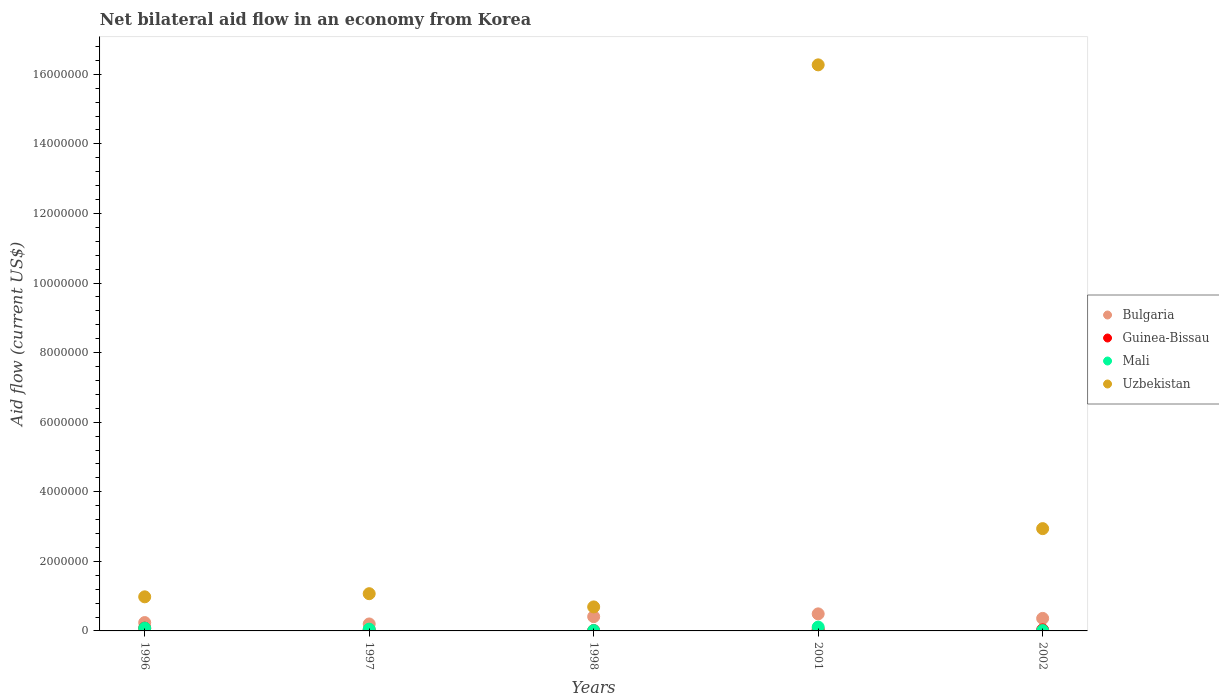Is the number of dotlines equal to the number of legend labels?
Make the answer very short. Yes. What is the net bilateral aid flow in Mali in 2002?
Your answer should be compact. 10000. Across all years, what is the minimum net bilateral aid flow in Guinea-Bissau?
Your response must be concise. 10000. In which year was the net bilateral aid flow in Uzbekistan maximum?
Ensure brevity in your answer.  2001. In which year was the net bilateral aid flow in Mali minimum?
Provide a succinct answer. 1998. What is the total net bilateral aid flow in Mali in the graph?
Make the answer very short. 2.60e+05. What is the difference between the net bilateral aid flow in Uzbekistan in 1998 and the net bilateral aid flow in Mali in 1997?
Your answer should be compact. 6.40e+05. What is the average net bilateral aid flow in Mali per year?
Ensure brevity in your answer.  5.20e+04. What is the difference between the highest and the second highest net bilateral aid flow in Mali?
Offer a very short reply. 3.00e+04. In how many years, is the net bilateral aid flow in Guinea-Bissau greater than the average net bilateral aid flow in Guinea-Bissau taken over all years?
Provide a short and direct response. 2. Is the sum of the net bilateral aid flow in Mali in 1997 and 1998 greater than the maximum net bilateral aid flow in Bulgaria across all years?
Give a very brief answer. No. Is it the case that in every year, the sum of the net bilateral aid flow in Mali and net bilateral aid flow in Bulgaria  is greater than the net bilateral aid flow in Uzbekistan?
Give a very brief answer. No. Is the net bilateral aid flow in Mali strictly greater than the net bilateral aid flow in Uzbekistan over the years?
Offer a terse response. No. Is the net bilateral aid flow in Guinea-Bissau strictly less than the net bilateral aid flow in Bulgaria over the years?
Provide a succinct answer. Yes. How many years are there in the graph?
Offer a very short reply. 5. What is the difference between two consecutive major ticks on the Y-axis?
Keep it short and to the point. 2.00e+06. Are the values on the major ticks of Y-axis written in scientific E-notation?
Keep it short and to the point. No. Does the graph contain any zero values?
Offer a terse response. No. Does the graph contain grids?
Give a very brief answer. No. How many legend labels are there?
Ensure brevity in your answer.  4. How are the legend labels stacked?
Your answer should be very brief. Vertical. What is the title of the graph?
Provide a short and direct response. Net bilateral aid flow in an economy from Korea. Does "American Samoa" appear as one of the legend labels in the graph?
Your answer should be compact. No. What is the Aid flow (current US$) of Guinea-Bissau in 1996?
Give a very brief answer. 8.00e+04. What is the Aid flow (current US$) in Mali in 1996?
Give a very brief answer. 8.00e+04. What is the Aid flow (current US$) of Uzbekistan in 1996?
Provide a succinct answer. 9.80e+05. What is the Aid flow (current US$) of Bulgaria in 1997?
Provide a succinct answer. 2.00e+05. What is the Aid flow (current US$) in Guinea-Bissau in 1997?
Provide a short and direct response. 3.00e+04. What is the Aid flow (current US$) in Mali in 1997?
Your answer should be very brief. 5.00e+04. What is the Aid flow (current US$) in Uzbekistan in 1997?
Your response must be concise. 1.07e+06. What is the Aid flow (current US$) of Mali in 1998?
Ensure brevity in your answer.  10000. What is the Aid flow (current US$) in Uzbekistan in 1998?
Your answer should be compact. 6.90e+05. What is the Aid flow (current US$) in Mali in 2001?
Provide a succinct answer. 1.10e+05. What is the Aid flow (current US$) in Uzbekistan in 2001?
Make the answer very short. 1.63e+07. What is the Aid flow (current US$) of Uzbekistan in 2002?
Give a very brief answer. 2.94e+06. Across all years, what is the maximum Aid flow (current US$) of Guinea-Bissau?
Provide a short and direct response. 8.00e+04. Across all years, what is the maximum Aid flow (current US$) in Mali?
Your answer should be compact. 1.10e+05. Across all years, what is the maximum Aid flow (current US$) of Uzbekistan?
Provide a succinct answer. 1.63e+07. Across all years, what is the minimum Aid flow (current US$) of Guinea-Bissau?
Your response must be concise. 10000. Across all years, what is the minimum Aid flow (current US$) of Mali?
Provide a succinct answer. 10000. Across all years, what is the minimum Aid flow (current US$) of Uzbekistan?
Ensure brevity in your answer.  6.90e+05. What is the total Aid flow (current US$) of Bulgaria in the graph?
Provide a succinct answer. 1.70e+06. What is the total Aid flow (current US$) of Uzbekistan in the graph?
Provide a short and direct response. 2.20e+07. What is the difference between the Aid flow (current US$) of Bulgaria in 1996 and that in 1997?
Provide a succinct answer. 4.00e+04. What is the difference between the Aid flow (current US$) in Uzbekistan in 1996 and that in 1998?
Offer a terse response. 2.90e+05. What is the difference between the Aid flow (current US$) of Guinea-Bissau in 1996 and that in 2001?
Offer a terse response. 4.00e+04. What is the difference between the Aid flow (current US$) of Uzbekistan in 1996 and that in 2001?
Make the answer very short. -1.53e+07. What is the difference between the Aid flow (current US$) of Guinea-Bissau in 1996 and that in 2002?
Provide a short and direct response. 5.00e+04. What is the difference between the Aid flow (current US$) of Mali in 1996 and that in 2002?
Provide a short and direct response. 7.00e+04. What is the difference between the Aid flow (current US$) of Uzbekistan in 1996 and that in 2002?
Provide a short and direct response. -1.96e+06. What is the difference between the Aid flow (current US$) of Mali in 1997 and that in 1998?
Offer a very short reply. 4.00e+04. What is the difference between the Aid flow (current US$) in Uzbekistan in 1997 and that in 1998?
Ensure brevity in your answer.  3.80e+05. What is the difference between the Aid flow (current US$) of Uzbekistan in 1997 and that in 2001?
Provide a short and direct response. -1.52e+07. What is the difference between the Aid flow (current US$) in Guinea-Bissau in 1997 and that in 2002?
Your answer should be compact. 0. What is the difference between the Aid flow (current US$) of Uzbekistan in 1997 and that in 2002?
Your answer should be very brief. -1.87e+06. What is the difference between the Aid flow (current US$) in Guinea-Bissau in 1998 and that in 2001?
Offer a very short reply. -3.00e+04. What is the difference between the Aid flow (current US$) of Mali in 1998 and that in 2001?
Provide a short and direct response. -1.00e+05. What is the difference between the Aid flow (current US$) of Uzbekistan in 1998 and that in 2001?
Keep it short and to the point. -1.56e+07. What is the difference between the Aid flow (current US$) of Bulgaria in 1998 and that in 2002?
Your response must be concise. 5.00e+04. What is the difference between the Aid flow (current US$) of Guinea-Bissau in 1998 and that in 2002?
Make the answer very short. -2.00e+04. What is the difference between the Aid flow (current US$) of Uzbekistan in 1998 and that in 2002?
Keep it short and to the point. -2.25e+06. What is the difference between the Aid flow (current US$) in Bulgaria in 2001 and that in 2002?
Offer a terse response. 1.30e+05. What is the difference between the Aid flow (current US$) of Uzbekistan in 2001 and that in 2002?
Your response must be concise. 1.33e+07. What is the difference between the Aid flow (current US$) in Bulgaria in 1996 and the Aid flow (current US$) in Guinea-Bissau in 1997?
Provide a short and direct response. 2.10e+05. What is the difference between the Aid flow (current US$) of Bulgaria in 1996 and the Aid flow (current US$) of Uzbekistan in 1997?
Offer a very short reply. -8.30e+05. What is the difference between the Aid flow (current US$) of Guinea-Bissau in 1996 and the Aid flow (current US$) of Uzbekistan in 1997?
Your answer should be very brief. -9.90e+05. What is the difference between the Aid flow (current US$) of Mali in 1996 and the Aid flow (current US$) of Uzbekistan in 1997?
Provide a short and direct response. -9.90e+05. What is the difference between the Aid flow (current US$) of Bulgaria in 1996 and the Aid flow (current US$) of Uzbekistan in 1998?
Your answer should be compact. -4.50e+05. What is the difference between the Aid flow (current US$) of Guinea-Bissau in 1996 and the Aid flow (current US$) of Uzbekistan in 1998?
Keep it short and to the point. -6.10e+05. What is the difference between the Aid flow (current US$) of Mali in 1996 and the Aid flow (current US$) of Uzbekistan in 1998?
Provide a short and direct response. -6.10e+05. What is the difference between the Aid flow (current US$) of Bulgaria in 1996 and the Aid flow (current US$) of Mali in 2001?
Provide a short and direct response. 1.30e+05. What is the difference between the Aid flow (current US$) of Bulgaria in 1996 and the Aid flow (current US$) of Uzbekistan in 2001?
Keep it short and to the point. -1.60e+07. What is the difference between the Aid flow (current US$) of Guinea-Bissau in 1996 and the Aid flow (current US$) of Mali in 2001?
Offer a terse response. -3.00e+04. What is the difference between the Aid flow (current US$) in Guinea-Bissau in 1996 and the Aid flow (current US$) in Uzbekistan in 2001?
Your answer should be very brief. -1.62e+07. What is the difference between the Aid flow (current US$) of Mali in 1996 and the Aid flow (current US$) of Uzbekistan in 2001?
Your response must be concise. -1.62e+07. What is the difference between the Aid flow (current US$) of Bulgaria in 1996 and the Aid flow (current US$) of Guinea-Bissau in 2002?
Give a very brief answer. 2.10e+05. What is the difference between the Aid flow (current US$) in Bulgaria in 1996 and the Aid flow (current US$) in Mali in 2002?
Keep it short and to the point. 2.30e+05. What is the difference between the Aid flow (current US$) in Bulgaria in 1996 and the Aid flow (current US$) in Uzbekistan in 2002?
Give a very brief answer. -2.70e+06. What is the difference between the Aid flow (current US$) of Guinea-Bissau in 1996 and the Aid flow (current US$) of Uzbekistan in 2002?
Provide a succinct answer. -2.86e+06. What is the difference between the Aid flow (current US$) in Mali in 1996 and the Aid flow (current US$) in Uzbekistan in 2002?
Provide a short and direct response. -2.86e+06. What is the difference between the Aid flow (current US$) in Bulgaria in 1997 and the Aid flow (current US$) in Guinea-Bissau in 1998?
Give a very brief answer. 1.90e+05. What is the difference between the Aid flow (current US$) in Bulgaria in 1997 and the Aid flow (current US$) in Uzbekistan in 1998?
Ensure brevity in your answer.  -4.90e+05. What is the difference between the Aid flow (current US$) of Guinea-Bissau in 1997 and the Aid flow (current US$) of Mali in 1998?
Your response must be concise. 2.00e+04. What is the difference between the Aid flow (current US$) in Guinea-Bissau in 1997 and the Aid flow (current US$) in Uzbekistan in 1998?
Give a very brief answer. -6.60e+05. What is the difference between the Aid flow (current US$) of Mali in 1997 and the Aid flow (current US$) of Uzbekistan in 1998?
Offer a very short reply. -6.40e+05. What is the difference between the Aid flow (current US$) of Bulgaria in 1997 and the Aid flow (current US$) of Mali in 2001?
Your response must be concise. 9.00e+04. What is the difference between the Aid flow (current US$) in Bulgaria in 1997 and the Aid flow (current US$) in Uzbekistan in 2001?
Ensure brevity in your answer.  -1.61e+07. What is the difference between the Aid flow (current US$) in Guinea-Bissau in 1997 and the Aid flow (current US$) in Uzbekistan in 2001?
Provide a succinct answer. -1.62e+07. What is the difference between the Aid flow (current US$) in Mali in 1997 and the Aid flow (current US$) in Uzbekistan in 2001?
Offer a very short reply. -1.62e+07. What is the difference between the Aid flow (current US$) in Bulgaria in 1997 and the Aid flow (current US$) in Guinea-Bissau in 2002?
Provide a short and direct response. 1.70e+05. What is the difference between the Aid flow (current US$) in Bulgaria in 1997 and the Aid flow (current US$) in Mali in 2002?
Your response must be concise. 1.90e+05. What is the difference between the Aid flow (current US$) in Bulgaria in 1997 and the Aid flow (current US$) in Uzbekistan in 2002?
Offer a terse response. -2.74e+06. What is the difference between the Aid flow (current US$) of Guinea-Bissau in 1997 and the Aid flow (current US$) of Uzbekistan in 2002?
Your answer should be very brief. -2.91e+06. What is the difference between the Aid flow (current US$) of Mali in 1997 and the Aid flow (current US$) of Uzbekistan in 2002?
Offer a very short reply. -2.89e+06. What is the difference between the Aid flow (current US$) in Bulgaria in 1998 and the Aid flow (current US$) in Guinea-Bissau in 2001?
Keep it short and to the point. 3.70e+05. What is the difference between the Aid flow (current US$) of Bulgaria in 1998 and the Aid flow (current US$) of Mali in 2001?
Give a very brief answer. 3.00e+05. What is the difference between the Aid flow (current US$) of Bulgaria in 1998 and the Aid flow (current US$) of Uzbekistan in 2001?
Offer a very short reply. -1.59e+07. What is the difference between the Aid flow (current US$) in Guinea-Bissau in 1998 and the Aid flow (current US$) in Mali in 2001?
Give a very brief answer. -1.00e+05. What is the difference between the Aid flow (current US$) of Guinea-Bissau in 1998 and the Aid flow (current US$) of Uzbekistan in 2001?
Ensure brevity in your answer.  -1.63e+07. What is the difference between the Aid flow (current US$) in Mali in 1998 and the Aid flow (current US$) in Uzbekistan in 2001?
Ensure brevity in your answer.  -1.63e+07. What is the difference between the Aid flow (current US$) of Bulgaria in 1998 and the Aid flow (current US$) of Guinea-Bissau in 2002?
Make the answer very short. 3.80e+05. What is the difference between the Aid flow (current US$) in Bulgaria in 1998 and the Aid flow (current US$) in Mali in 2002?
Offer a very short reply. 4.00e+05. What is the difference between the Aid flow (current US$) of Bulgaria in 1998 and the Aid flow (current US$) of Uzbekistan in 2002?
Ensure brevity in your answer.  -2.53e+06. What is the difference between the Aid flow (current US$) of Guinea-Bissau in 1998 and the Aid flow (current US$) of Uzbekistan in 2002?
Give a very brief answer. -2.93e+06. What is the difference between the Aid flow (current US$) in Mali in 1998 and the Aid flow (current US$) in Uzbekistan in 2002?
Your answer should be compact. -2.93e+06. What is the difference between the Aid flow (current US$) of Bulgaria in 2001 and the Aid flow (current US$) of Guinea-Bissau in 2002?
Provide a short and direct response. 4.60e+05. What is the difference between the Aid flow (current US$) in Bulgaria in 2001 and the Aid flow (current US$) in Uzbekistan in 2002?
Your answer should be very brief. -2.45e+06. What is the difference between the Aid flow (current US$) in Guinea-Bissau in 2001 and the Aid flow (current US$) in Mali in 2002?
Your answer should be very brief. 3.00e+04. What is the difference between the Aid flow (current US$) of Guinea-Bissau in 2001 and the Aid flow (current US$) of Uzbekistan in 2002?
Your answer should be very brief. -2.90e+06. What is the difference between the Aid flow (current US$) in Mali in 2001 and the Aid flow (current US$) in Uzbekistan in 2002?
Your answer should be very brief. -2.83e+06. What is the average Aid flow (current US$) of Bulgaria per year?
Make the answer very short. 3.40e+05. What is the average Aid flow (current US$) of Guinea-Bissau per year?
Ensure brevity in your answer.  3.80e+04. What is the average Aid flow (current US$) in Mali per year?
Give a very brief answer. 5.20e+04. What is the average Aid flow (current US$) in Uzbekistan per year?
Provide a short and direct response. 4.39e+06. In the year 1996, what is the difference between the Aid flow (current US$) in Bulgaria and Aid flow (current US$) in Guinea-Bissau?
Give a very brief answer. 1.60e+05. In the year 1996, what is the difference between the Aid flow (current US$) in Bulgaria and Aid flow (current US$) in Mali?
Ensure brevity in your answer.  1.60e+05. In the year 1996, what is the difference between the Aid flow (current US$) in Bulgaria and Aid flow (current US$) in Uzbekistan?
Give a very brief answer. -7.40e+05. In the year 1996, what is the difference between the Aid flow (current US$) in Guinea-Bissau and Aid flow (current US$) in Uzbekistan?
Keep it short and to the point. -9.00e+05. In the year 1996, what is the difference between the Aid flow (current US$) in Mali and Aid flow (current US$) in Uzbekistan?
Give a very brief answer. -9.00e+05. In the year 1997, what is the difference between the Aid flow (current US$) of Bulgaria and Aid flow (current US$) of Guinea-Bissau?
Your answer should be very brief. 1.70e+05. In the year 1997, what is the difference between the Aid flow (current US$) in Bulgaria and Aid flow (current US$) in Mali?
Make the answer very short. 1.50e+05. In the year 1997, what is the difference between the Aid flow (current US$) of Bulgaria and Aid flow (current US$) of Uzbekistan?
Provide a succinct answer. -8.70e+05. In the year 1997, what is the difference between the Aid flow (current US$) of Guinea-Bissau and Aid flow (current US$) of Uzbekistan?
Keep it short and to the point. -1.04e+06. In the year 1997, what is the difference between the Aid flow (current US$) of Mali and Aid flow (current US$) of Uzbekistan?
Provide a succinct answer. -1.02e+06. In the year 1998, what is the difference between the Aid flow (current US$) of Bulgaria and Aid flow (current US$) of Mali?
Keep it short and to the point. 4.00e+05. In the year 1998, what is the difference between the Aid flow (current US$) in Bulgaria and Aid flow (current US$) in Uzbekistan?
Provide a succinct answer. -2.80e+05. In the year 1998, what is the difference between the Aid flow (current US$) of Guinea-Bissau and Aid flow (current US$) of Uzbekistan?
Provide a short and direct response. -6.80e+05. In the year 1998, what is the difference between the Aid flow (current US$) in Mali and Aid flow (current US$) in Uzbekistan?
Provide a succinct answer. -6.80e+05. In the year 2001, what is the difference between the Aid flow (current US$) in Bulgaria and Aid flow (current US$) in Uzbekistan?
Give a very brief answer. -1.58e+07. In the year 2001, what is the difference between the Aid flow (current US$) of Guinea-Bissau and Aid flow (current US$) of Mali?
Your response must be concise. -7.00e+04. In the year 2001, what is the difference between the Aid flow (current US$) of Guinea-Bissau and Aid flow (current US$) of Uzbekistan?
Make the answer very short. -1.62e+07. In the year 2001, what is the difference between the Aid flow (current US$) in Mali and Aid flow (current US$) in Uzbekistan?
Your response must be concise. -1.62e+07. In the year 2002, what is the difference between the Aid flow (current US$) in Bulgaria and Aid flow (current US$) in Uzbekistan?
Offer a very short reply. -2.58e+06. In the year 2002, what is the difference between the Aid flow (current US$) of Guinea-Bissau and Aid flow (current US$) of Uzbekistan?
Make the answer very short. -2.91e+06. In the year 2002, what is the difference between the Aid flow (current US$) in Mali and Aid flow (current US$) in Uzbekistan?
Give a very brief answer. -2.93e+06. What is the ratio of the Aid flow (current US$) in Guinea-Bissau in 1996 to that in 1997?
Keep it short and to the point. 2.67. What is the ratio of the Aid flow (current US$) in Uzbekistan in 1996 to that in 1997?
Your answer should be compact. 0.92. What is the ratio of the Aid flow (current US$) of Bulgaria in 1996 to that in 1998?
Offer a very short reply. 0.59. What is the ratio of the Aid flow (current US$) of Guinea-Bissau in 1996 to that in 1998?
Your response must be concise. 8. What is the ratio of the Aid flow (current US$) in Mali in 1996 to that in 1998?
Your answer should be very brief. 8. What is the ratio of the Aid flow (current US$) of Uzbekistan in 1996 to that in 1998?
Keep it short and to the point. 1.42. What is the ratio of the Aid flow (current US$) in Bulgaria in 1996 to that in 2001?
Provide a short and direct response. 0.49. What is the ratio of the Aid flow (current US$) of Mali in 1996 to that in 2001?
Your response must be concise. 0.73. What is the ratio of the Aid flow (current US$) in Uzbekistan in 1996 to that in 2001?
Keep it short and to the point. 0.06. What is the ratio of the Aid flow (current US$) in Bulgaria in 1996 to that in 2002?
Your response must be concise. 0.67. What is the ratio of the Aid flow (current US$) of Guinea-Bissau in 1996 to that in 2002?
Provide a short and direct response. 2.67. What is the ratio of the Aid flow (current US$) in Bulgaria in 1997 to that in 1998?
Ensure brevity in your answer.  0.49. What is the ratio of the Aid flow (current US$) of Mali in 1997 to that in 1998?
Provide a succinct answer. 5. What is the ratio of the Aid flow (current US$) of Uzbekistan in 1997 to that in 1998?
Give a very brief answer. 1.55. What is the ratio of the Aid flow (current US$) of Bulgaria in 1997 to that in 2001?
Offer a very short reply. 0.41. What is the ratio of the Aid flow (current US$) of Mali in 1997 to that in 2001?
Make the answer very short. 0.45. What is the ratio of the Aid flow (current US$) of Uzbekistan in 1997 to that in 2001?
Provide a succinct answer. 0.07. What is the ratio of the Aid flow (current US$) in Bulgaria in 1997 to that in 2002?
Provide a short and direct response. 0.56. What is the ratio of the Aid flow (current US$) in Uzbekistan in 1997 to that in 2002?
Provide a succinct answer. 0.36. What is the ratio of the Aid flow (current US$) of Bulgaria in 1998 to that in 2001?
Provide a short and direct response. 0.84. What is the ratio of the Aid flow (current US$) in Guinea-Bissau in 1998 to that in 2001?
Your answer should be compact. 0.25. What is the ratio of the Aid flow (current US$) of Mali in 1998 to that in 2001?
Provide a short and direct response. 0.09. What is the ratio of the Aid flow (current US$) of Uzbekistan in 1998 to that in 2001?
Provide a short and direct response. 0.04. What is the ratio of the Aid flow (current US$) in Bulgaria in 1998 to that in 2002?
Your response must be concise. 1.14. What is the ratio of the Aid flow (current US$) in Guinea-Bissau in 1998 to that in 2002?
Ensure brevity in your answer.  0.33. What is the ratio of the Aid flow (current US$) in Uzbekistan in 1998 to that in 2002?
Provide a succinct answer. 0.23. What is the ratio of the Aid flow (current US$) of Bulgaria in 2001 to that in 2002?
Ensure brevity in your answer.  1.36. What is the ratio of the Aid flow (current US$) in Guinea-Bissau in 2001 to that in 2002?
Provide a succinct answer. 1.33. What is the ratio of the Aid flow (current US$) in Uzbekistan in 2001 to that in 2002?
Provide a short and direct response. 5.53. What is the difference between the highest and the second highest Aid flow (current US$) in Bulgaria?
Ensure brevity in your answer.  8.00e+04. What is the difference between the highest and the second highest Aid flow (current US$) of Mali?
Your response must be concise. 3.00e+04. What is the difference between the highest and the second highest Aid flow (current US$) in Uzbekistan?
Offer a terse response. 1.33e+07. What is the difference between the highest and the lowest Aid flow (current US$) in Bulgaria?
Give a very brief answer. 2.90e+05. What is the difference between the highest and the lowest Aid flow (current US$) of Guinea-Bissau?
Ensure brevity in your answer.  7.00e+04. What is the difference between the highest and the lowest Aid flow (current US$) in Uzbekistan?
Provide a succinct answer. 1.56e+07. 